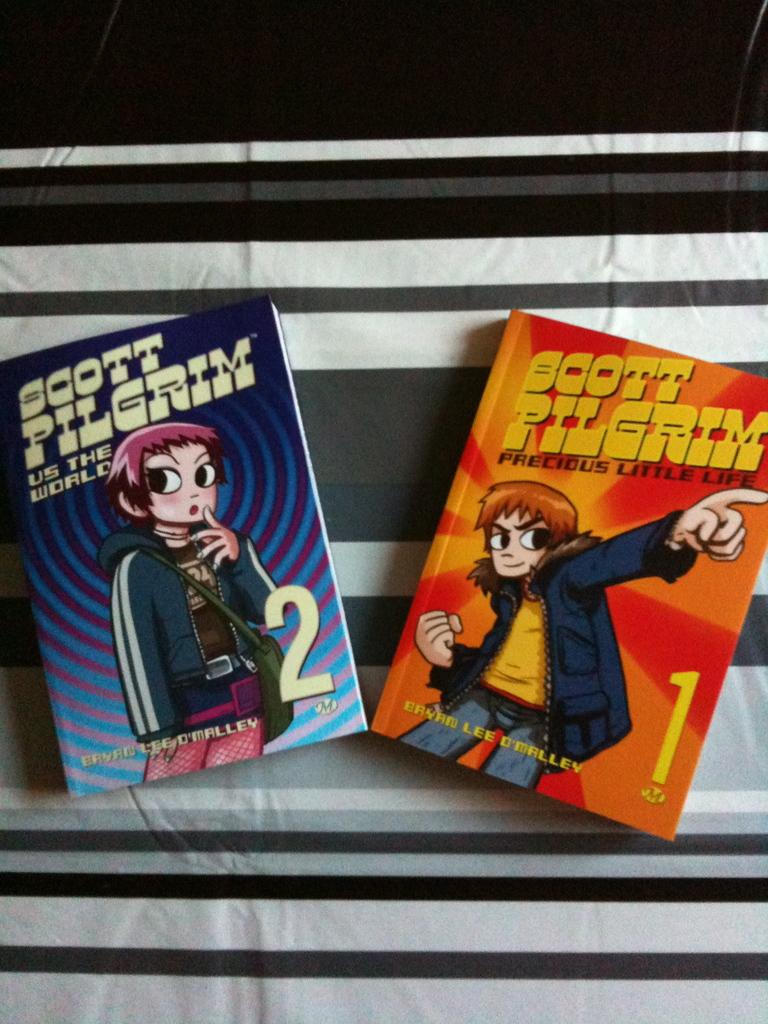<image>
Offer a succinct explanation of the picture presented. Two comic books titled Scott Pilerim placed on a fabric with stripes. 